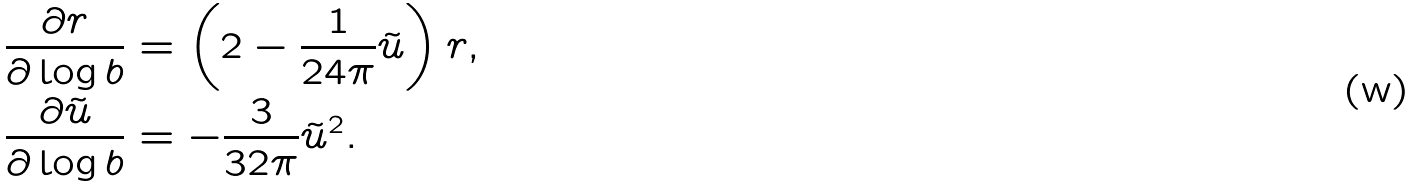Convert formula to latex. <formula><loc_0><loc_0><loc_500><loc_500>\frac { \partial r } { \partial \log b } & = \left ( 2 - \frac { 1 } { 2 4 \pi } \tilde { u } \right ) r , \\ \frac { \partial \tilde { u } } { \partial \log b } & = - \frac { 3 } { 3 2 \pi } \tilde { u } ^ { 2 } .</formula> 